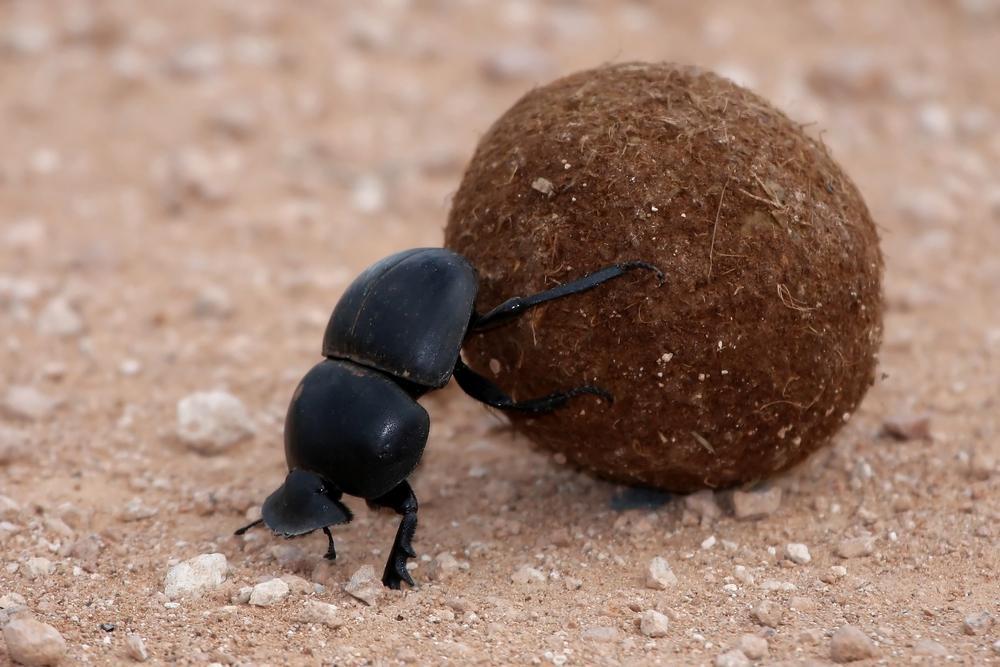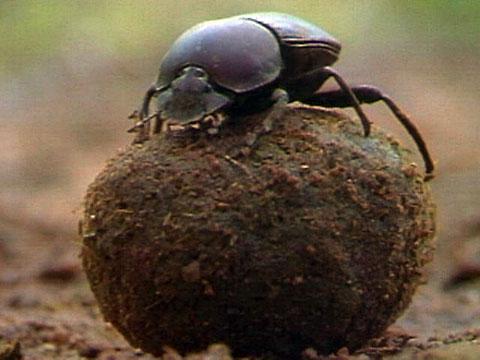The first image is the image on the left, the second image is the image on the right. Examine the images to the left and right. Is the description "An image contains two dung beetles." accurate? Answer yes or no. No. The first image is the image on the left, the second image is the image on the right. Considering the images on both sides, is "One image includes a beetle that is not in contact with a ball shape, and the other shows a beetle perched on a ball with its front legs touching the ground." valid? Answer yes or no. No. 